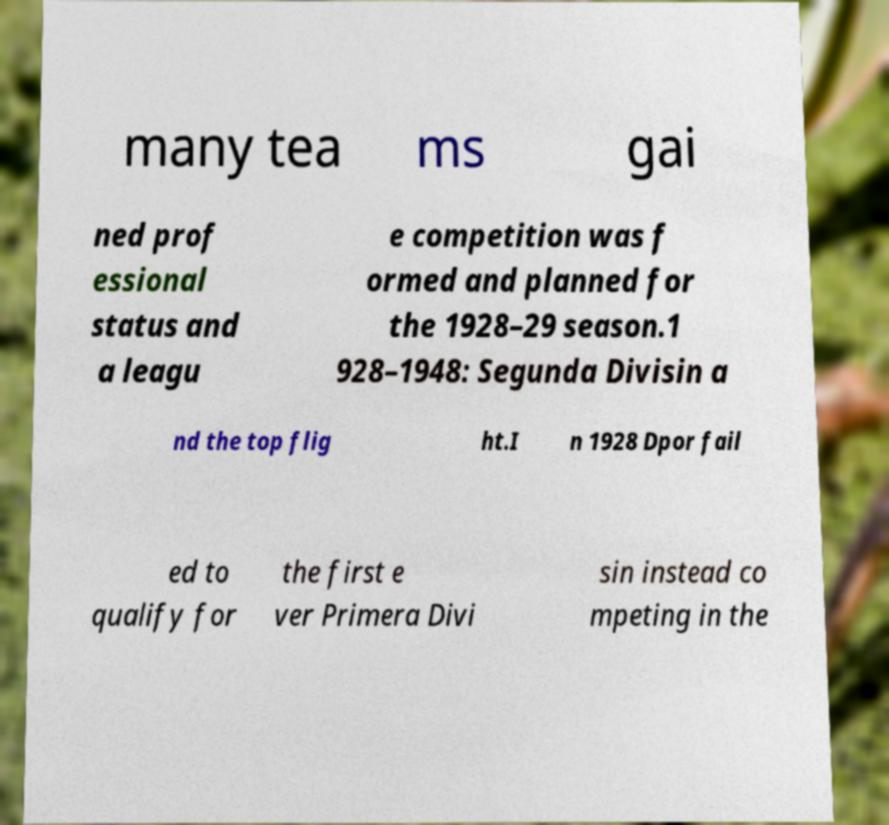Can you read and provide the text displayed in the image?This photo seems to have some interesting text. Can you extract and type it out for me? many tea ms gai ned prof essional status and a leagu e competition was f ormed and planned for the 1928–29 season.1 928–1948: Segunda Divisin a nd the top flig ht.I n 1928 Dpor fail ed to qualify for the first e ver Primera Divi sin instead co mpeting in the 